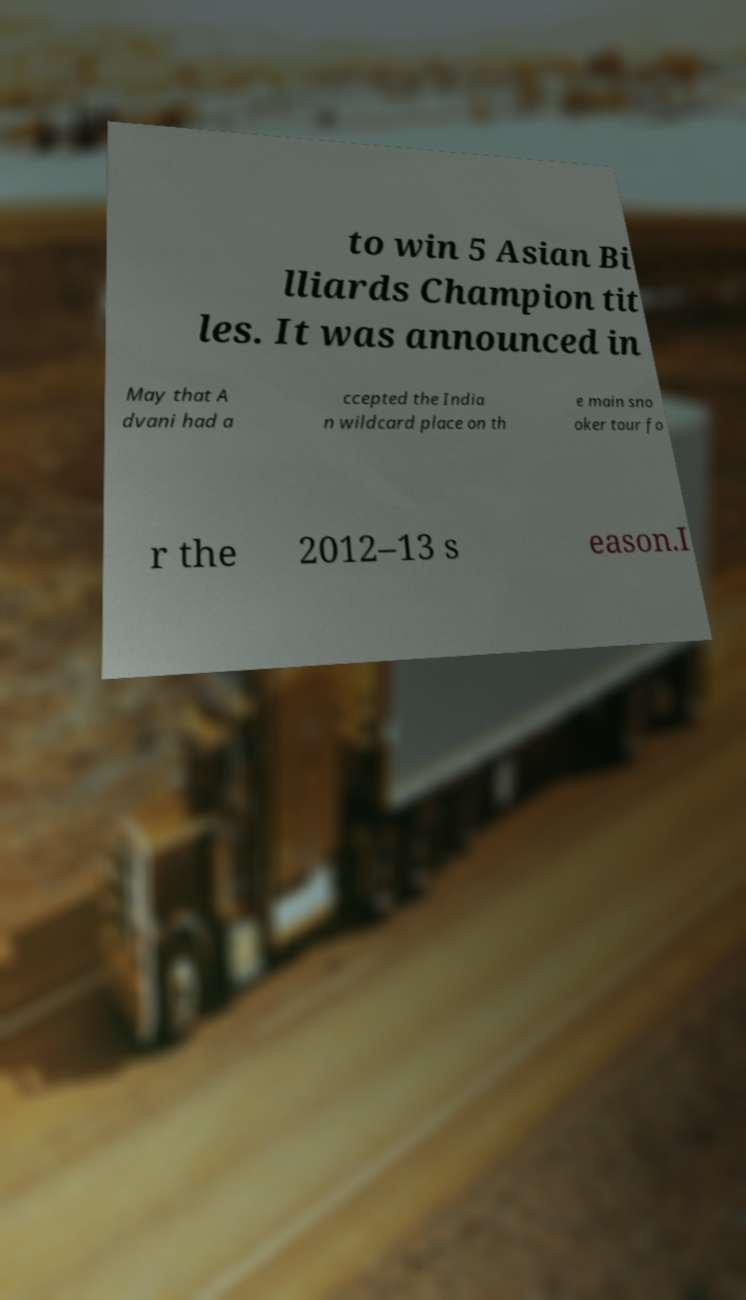I need the written content from this picture converted into text. Can you do that? to win 5 Asian Bi lliards Champion tit les. It was announced in May that A dvani had a ccepted the India n wildcard place on th e main sno oker tour fo r the 2012–13 s eason.I 